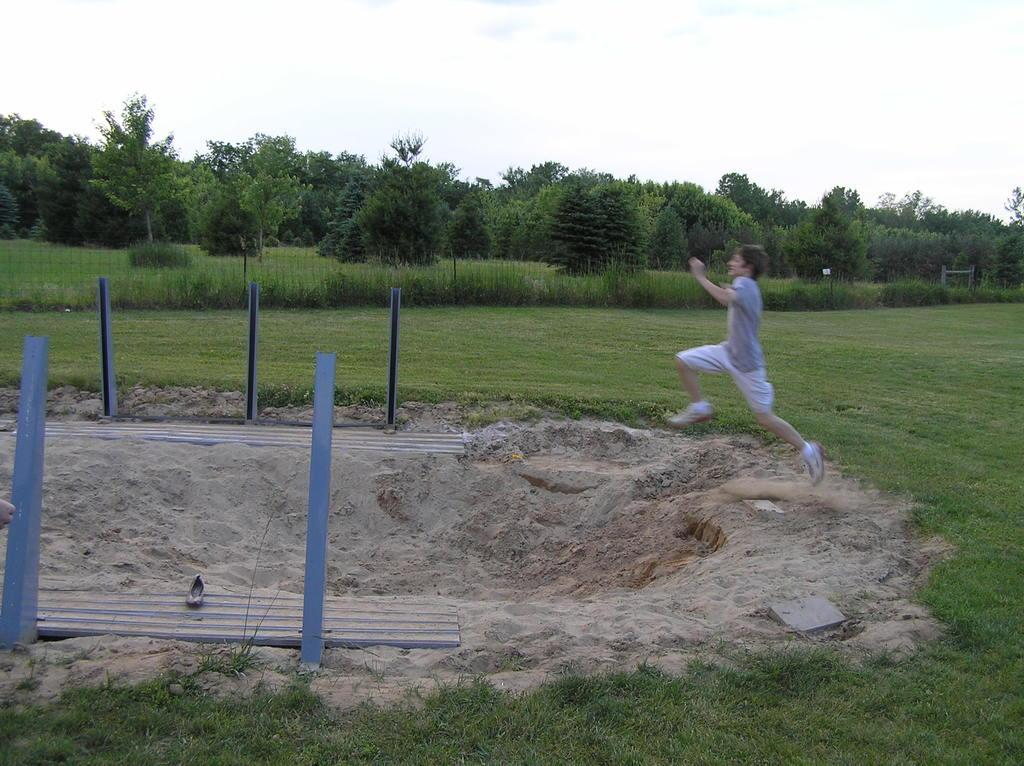What is the main subject of the image? There is a person in the image. What is the person doing in the image? The person is running and jumping. What surface is the person jumping onto? The person is jumping onto sand. What type of vegetation can be seen in the image? There is grass visible in the image. What can be seen in the background of the image? There are trees in the background of the image. How many geese are learning to make a list in the image? There are no geese or lists present in the image. 